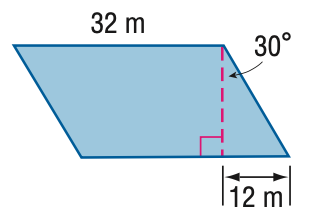Question: Find the area of the parallelogram. Round to the nearest tenth if necessary.
Choices:
A. 332.6
B. 543.1
C. 665.1
D. 768
Answer with the letter. Answer: C 